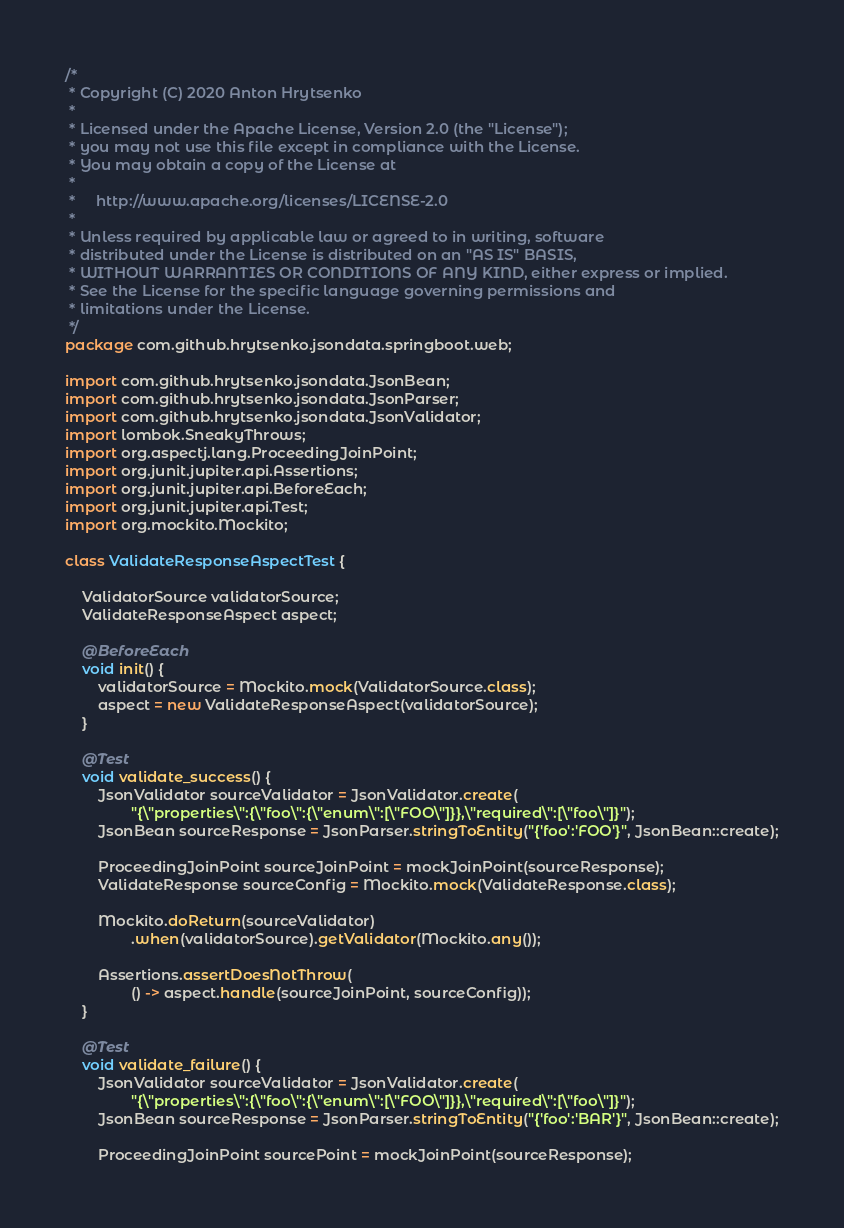Convert code to text. <code><loc_0><loc_0><loc_500><loc_500><_Java_>/*
 * Copyright (C) 2020 Anton Hrytsenko
 *
 * Licensed under the Apache License, Version 2.0 (the "License");
 * you may not use this file except in compliance with the License.
 * You may obtain a copy of the License at
 *
 *     http://www.apache.org/licenses/LICENSE-2.0
 *
 * Unless required by applicable law or agreed to in writing, software
 * distributed under the License is distributed on an "AS IS" BASIS,
 * WITHOUT WARRANTIES OR CONDITIONS OF ANY KIND, either express or implied.
 * See the License for the specific language governing permissions and
 * limitations under the License.
 */
package com.github.hrytsenko.jsondata.springboot.web;

import com.github.hrytsenko.jsondata.JsonBean;
import com.github.hrytsenko.jsondata.JsonParser;
import com.github.hrytsenko.jsondata.JsonValidator;
import lombok.SneakyThrows;
import org.aspectj.lang.ProceedingJoinPoint;
import org.junit.jupiter.api.Assertions;
import org.junit.jupiter.api.BeforeEach;
import org.junit.jupiter.api.Test;
import org.mockito.Mockito;

class ValidateResponseAspectTest {

    ValidatorSource validatorSource;
    ValidateResponseAspect aspect;

    @BeforeEach
    void init() {
        validatorSource = Mockito.mock(ValidatorSource.class);
        aspect = new ValidateResponseAspect(validatorSource);
    }

    @Test
    void validate_success() {
        JsonValidator sourceValidator = JsonValidator.create(
                "{\"properties\":{\"foo\":{\"enum\":[\"FOO\"]}},\"required\":[\"foo\"]}");
        JsonBean sourceResponse = JsonParser.stringToEntity("{'foo':'FOO'}", JsonBean::create);

        ProceedingJoinPoint sourceJoinPoint = mockJoinPoint(sourceResponse);
        ValidateResponse sourceConfig = Mockito.mock(ValidateResponse.class);

        Mockito.doReturn(sourceValidator)
                .when(validatorSource).getValidator(Mockito.any());

        Assertions.assertDoesNotThrow(
                () -> aspect.handle(sourceJoinPoint, sourceConfig));
    }

    @Test
    void validate_failure() {
        JsonValidator sourceValidator = JsonValidator.create(
                "{\"properties\":{\"foo\":{\"enum\":[\"FOO\"]}},\"required\":[\"foo\"]}");
        JsonBean sourceResponse = JsonParser.stringToEntity("{'foo':'BAR'}", JsonBean::create);

        ProceedingJoinPoint sourcePoint = mockJoinPoint(sourceResponse);</code> 